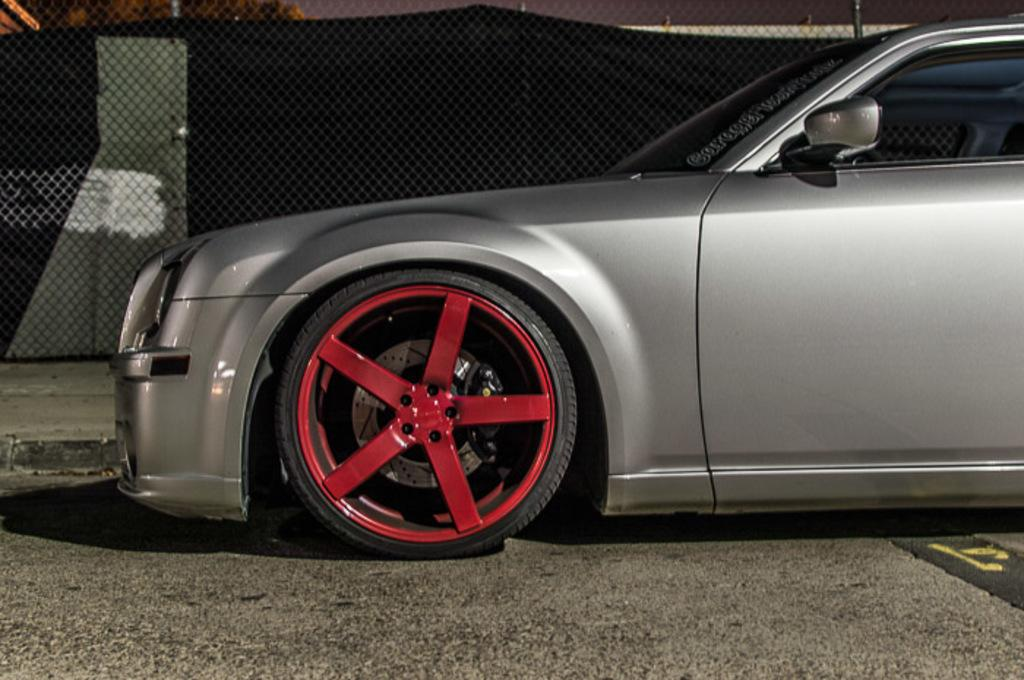What color is the car in the image? The car in the image is ash color. What is unique about the wheels of the car? The wheels of the car are red. Where is the car located in the image? The car is placed on the road. What can be seen in the background of the image? In the background of the image, there is a mesh, cloth, and rods. What type of stew is being cooked in the car's engine in the image? There is no stew or cooking activity present in the image; it features a car with red wheels on the road. What color is the silver ball in the image? There is no silver ball present in the image. 